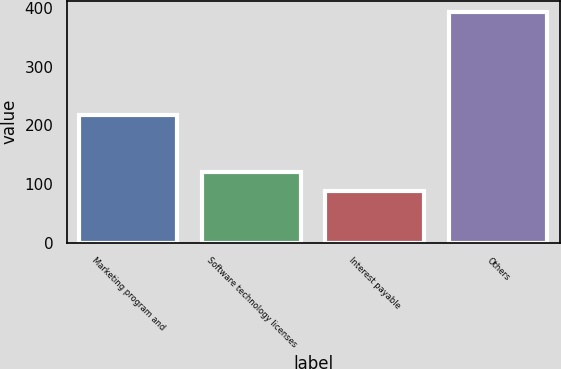Convert chart. <chart><loc_0><loc_0><loc_500><loc_500><bar_chart><fcel>Marketing program and<fcel>Software technology licenses<fcel>Interest payable<fcel>Others<nl><fcel>218<fcel>121<fcel>89<fcel>393<nl></chart> 